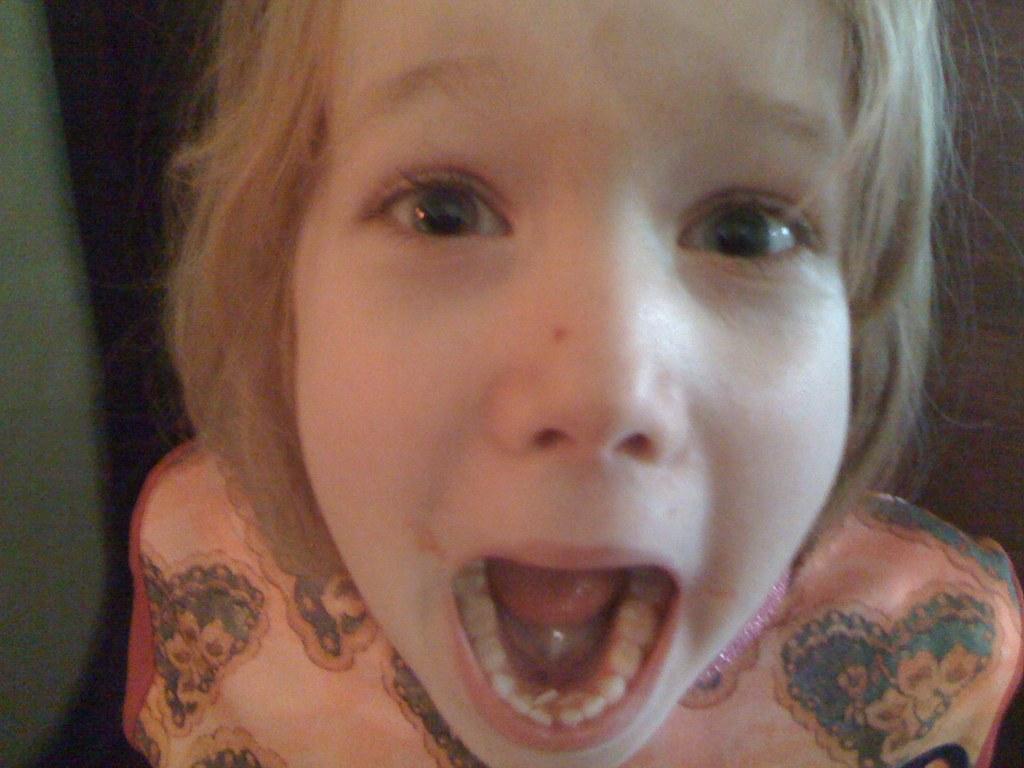How would you summarize this image in a sentence or two? In this image I can see a person is wearing peach color dress and the background is dark. 